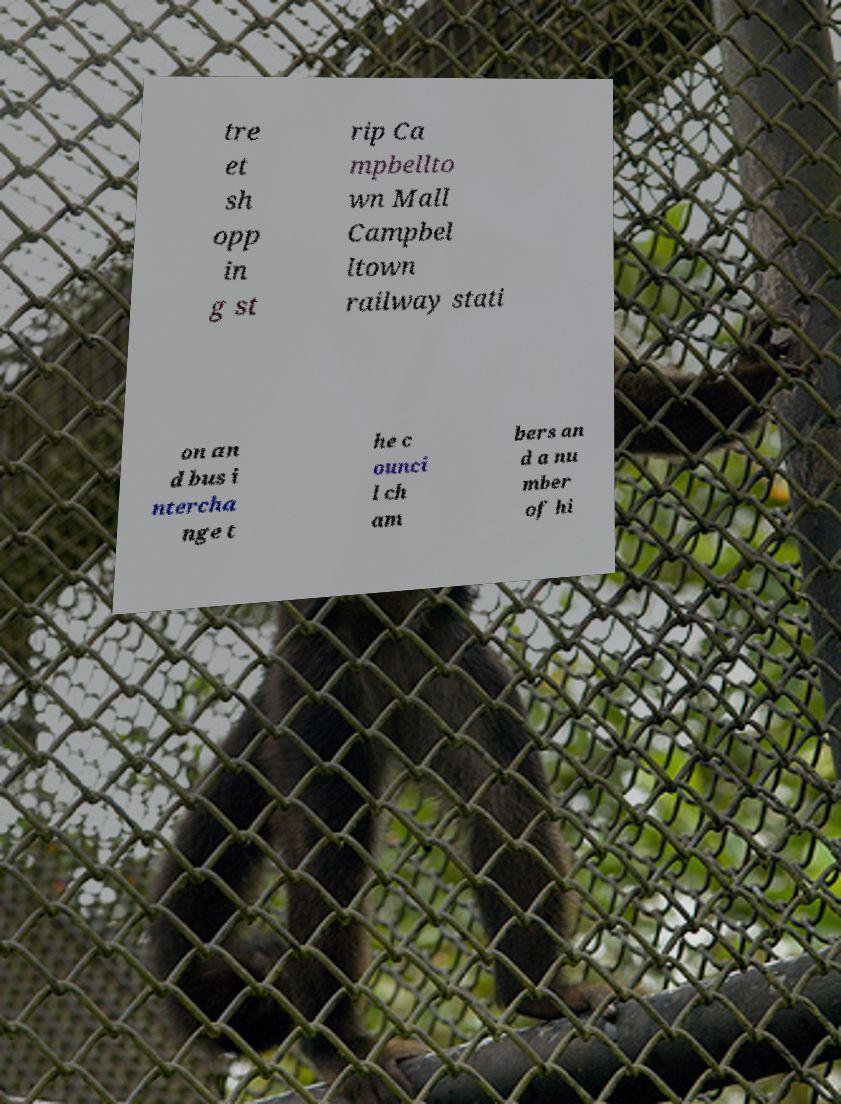Could you extract and type out the text from this image? tre et sh opp in g st rip Ca mpbellto wn Mall Campbel ltown railway stati on an d bus i ntercha nge t he c ounci l ch am bers an d a nu mber of hi 